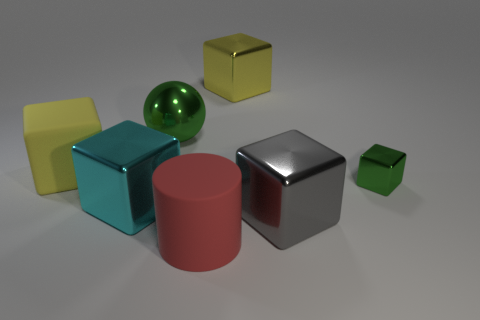Subtract all cyan cubes. How many cubes are left? 4 Subtract all yellow metallic cubes. How many cubes are left? 4 Subtract all red blocks. Subtract all blue balls. How many blocks are left? 5 Add 2 green balls. How many objects exist? 9 Subtract all cubes. How many objects are left? 2 Add 1 matte cylinders. How many matte cylinders exist? 2 Subtract 1 green spheres. How many objects are left? 6 Subtract all tiny cubes. Subtract all green spheres. How many objects are left? 5 Add 3 big red objects. How many big red objects are left? 4 